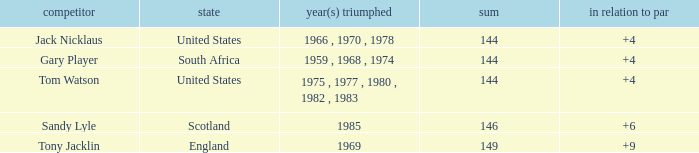What was England's total? 149.0. 